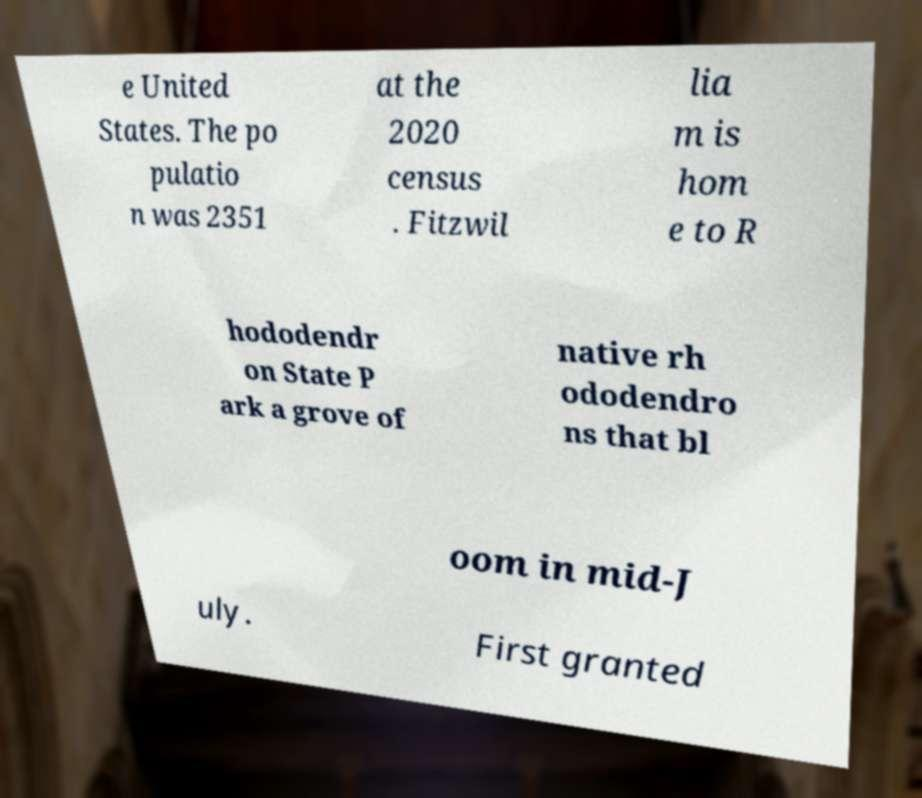For documentation purposes, I need the text within this image transcribed. Could you provide that? e United States. The po pulatio n was 2351 at the 2020 census . Fitzwil lia m is hom e to R hododendr on State P ark a grove of native rh ododendro ns that bl oom in mid-J uly. First granted 